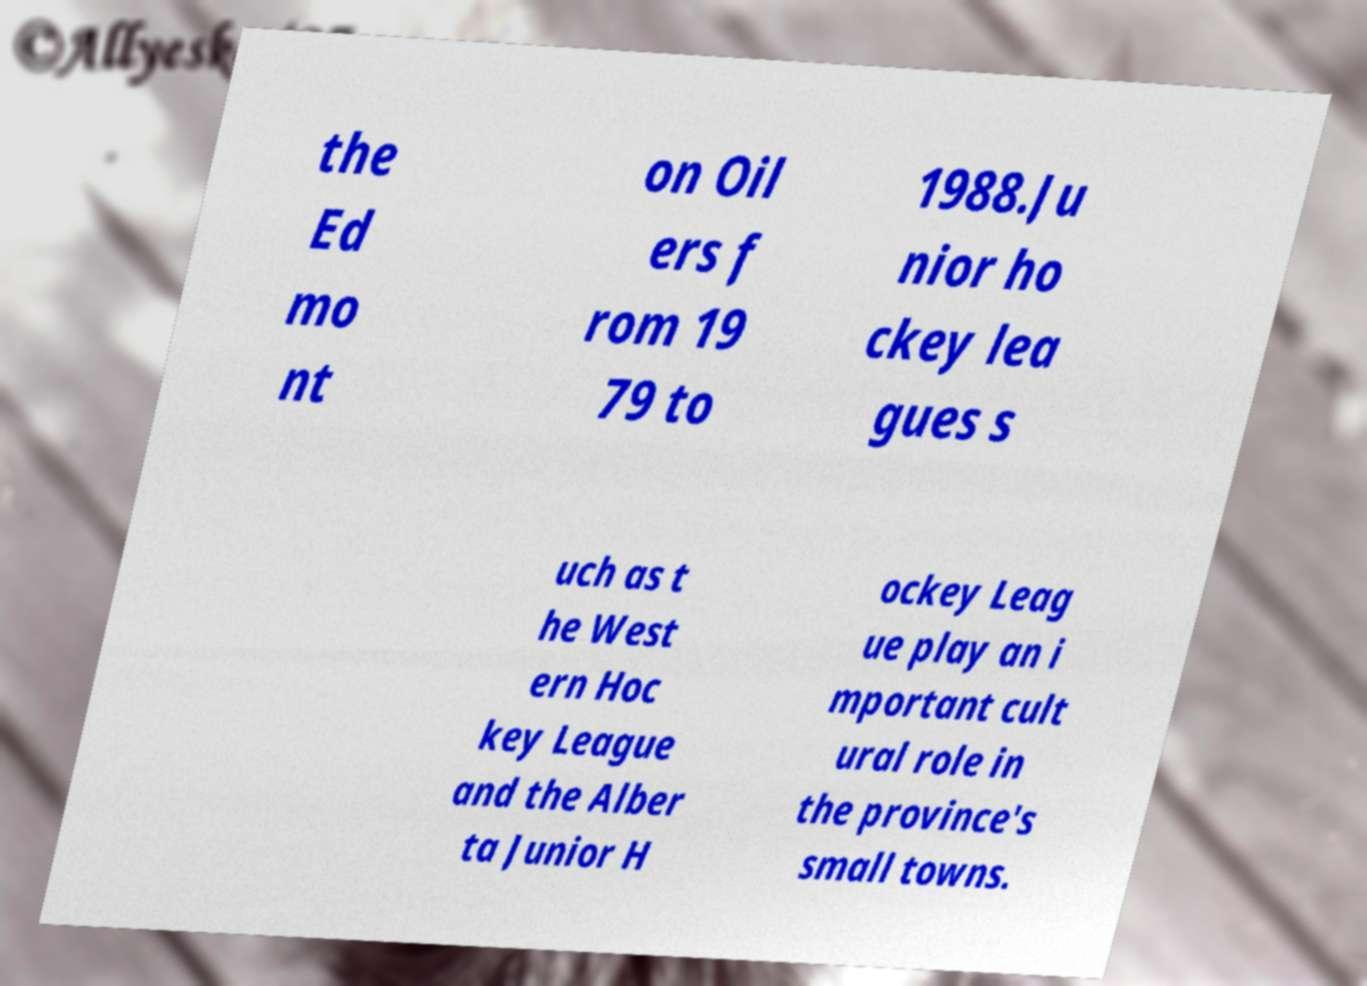For documentation purposes, I need the text within this image transcribed. Could you provide that? the Ed mo nt on Oil ers f rom 19 79 to 1988.Ju nior ho ckey lea gues s uch as t he West ern Hoc key League and the Alber ta Junior H ockey Leag ue play an i mportant cult ural role in the province's small towns. 